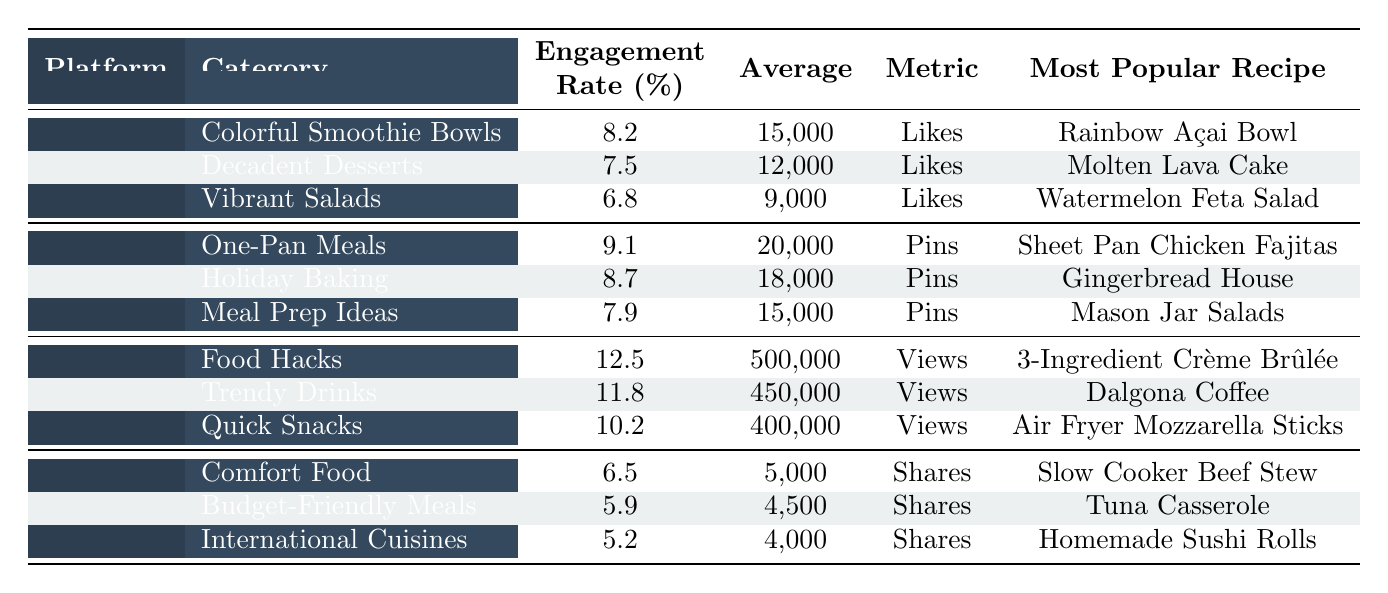What is the highest engagement rate among all platforms? The highest engagement rate listed in the table is for TikTok's "Food Hacks," which has an engagement rate of 12.5%.
Answer: 12.5% Which recipe category on Instagram has the most average likes? The "Colorful Smoothie Bowls" category on Instagram has the highest average likes, totaling 15,000.
Answer: 15,000 How many average pins does the "Holiday Baking" category have compared to "Meal Prep Ideas"? "Holiday Baking" has 18,000 average pins, while "Meal Prep Ideas" has 15,000. The difference is 18,000 - 15,000 = 3,000.
Answer: 3,000 Is "Dalgona Coffee" the most popular recipe for the "Trendy Drinks" category on TikTok? Yes, "Dalgona Coffee" is specifically mentioned as the most popular recipe in the "Trendy Drinks" category on TikTok.
Answer: Yes Which platform has the least engagement rate, and what is it? Facebook has the least engagement rate at 5.2% for the "International Cuisines" category, when comparing all platforms and categories.
Answer: 5.2% What is the average engagement rate for the "Comfort Food" and "Budget-Friendly Meals" categories on Facebook? The engagement rates are 6.5% for "Comfort Food" and 5.9% for "Budget-Friendly Meals." Therefore, the average engagement rate is (6.5 + 5.9) / 2 = 6.2%.
Answer: 6.2% Which recipe category across all platforms has the highest average metric, and what is that metric? The "Food Hacks" category on TikTok has the highest average metric with 500,000 average views.
Answer: 500,000 views Does "Mason Jar Salads" have a higher average likes compared to "Watermelon Feta Salad"? No, "Mason Jar Salads," which is under Pinterest, does not have likes listed, but comparing it to "Watermelon Feta Salad" at 9,000 average likes indicates that the latter has more.
Answer: No What is the total engagement rate for all categories listed under Pinterest? Adding the engagement rates: 9.1 + 8.7 + 7.9 = 25.7%. Therefore, the total engagement rate for Pinterest is 25.7%.
Answer: 25.7% Is it true that "Slow Cooker Beef Stew" is the most popular recipe for the "Comfort Food" category on Facebook? Yes, the table confirms that "Slow Cooker Beef Stew" is the most popular recipe in the "Comfort Food" category on Facebook.
Answer: Yes 